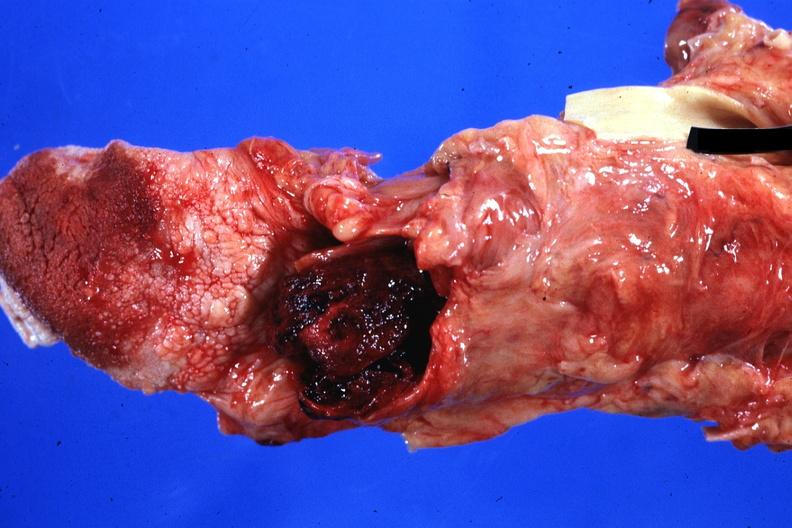what standing case of myeloproliferative disorder with terminal acute transformation and bleeding disorder?
Answer the question using a single word or phrase. Blood clot 